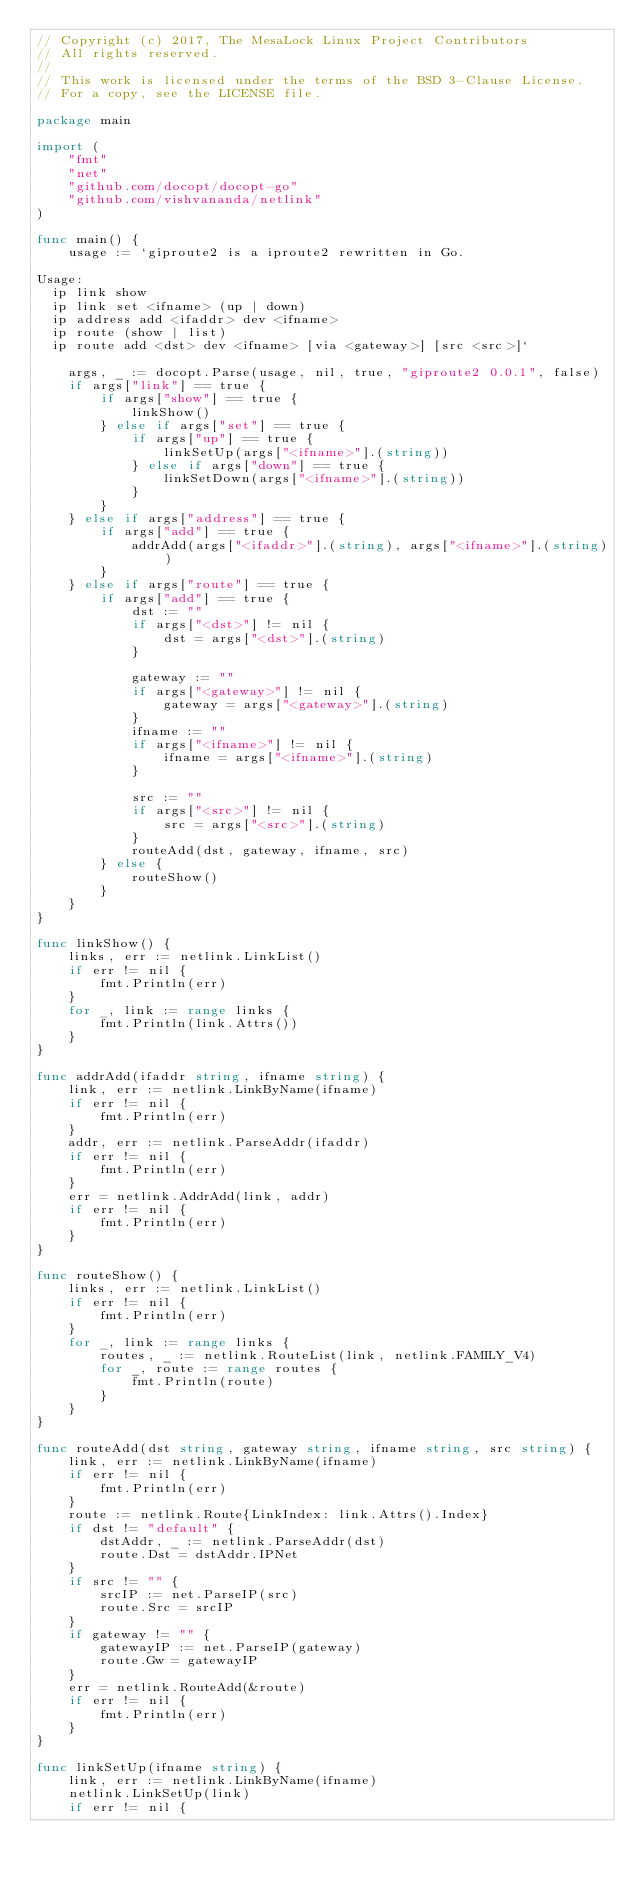Convert code to text. <code><loc_0><loc_0><loc_500><loc_500><_Go_>// Copyright (c) 2017, The MesaLock Linux Project Contributors
// All rights reserved.
//
// This work is licensed under the terms of the BSD 3-Clause License.
// For a copy, see the LICENSE file.

package main

import (
    "fmt"
    "net"
    "github.com/docopt/docopt-go"
    "github.com/vishvananda/netlink"
)

func main() {
    usage := `giproute2 is a iproute2 rewritten in Go.

Usage:
  ip link show
  ip link set <ifname> (up | down)
  ip address add <ifaddr> dev <ifname>
  ip route (show | list)
  ip route add <dst> dev <ifname> [via <gateway>] [src <src>]`

    args, _ := docopt.Parse(usage, nil, true, "giproute2 0.0.1", false)
    if args["link"] == true {
        if args["show"] == true {
            linkShow()
        } else if args["set"] == true {
            if args["up"] == true {
                linkSetUp(args["<ifname>"].(string))
            } else if args["down"] == true {
                linkSetDown(args["<ifname>"].(string))
            }
        }
    } else if args["address"] == true {
        if args["add"] == true {
            addrAdd(args["<ifaddr>"].(string), args["<ifname>"].(string))
        }
    } else if args["route"] == true {
        if args["add"] == true {
            dst := ""
            if args["<dst>"] != nil {
                dst = args["<dst>"].(string)
            }

            gateway := ""
            if args["<gateway>"] != nil {
                gateway = args["<gateway>"].(string)
            }
            ifname := ""
            if args["<ifname>"] != nil {
                ifname = args["<ifname>"].(string)
            }

            src := ""
            if args["<src>"] != nil {
                src = args["<src>"].(string)
            }
            routeAdd(dst, gateway, ifname, src)
        } else {
            routeShow()
        }
    }
}

func linkShow() {
    links, err := netlink.LinkList()
    if err != nil {
        fmt.Println(err)
    }
    for _, link := range links {
        fmt.Println(link.Attrs())
    }
}

func addrAdd(ifaddr string, ifname string) {
    link, err := netlink.LinkByName(ifname)
    if err != nil {
        fmt.Println(err)
    }
    addr, err := netlink.ParseAddr(ifaddr)
    if err != nil {
        fmt.Println(err)
    }
    err = netlink.AddrAdd(link, addr)
    if err != nil {
        fmt.Println(err)
    }
}

func routeShow() {
    links, err := netlink.LinkList()
    if err != nil {
        fmt.Println(err)
    }
    for _, link := range links {
        routes, _ := netlink.RouteList(link, netlink.FAMILY_V4)
        for _, route := range routes {
            fmt.Println(route)
        }
    }
}

func routeAdd(dst string, gateway string, ifname string, src string) {
    link, err := netlink.LinkByName(ifname)
    if err != nil {
        fmt.Println(err)
    }
    route := netlink.Route{LinkIndex: link.Attrs().Index}
    if dst != "default" {
        dstAddr, _ := netlink.ParseAddr(dst)
        route.Dst = dstAddr.IPNet
    }
    if src != "" {
        srcIP := net.ParseIP(src)
        route.Src = srcIP
    }
    if gateway != "" {
        gatewayIP := net.ParseIP(gateway)
        route.Gw = gatewayIP
    }
    err = netlink.RouteAdd(&route)
    if err != nil {
        fmt.Println(err)
    }
}

func linkSetUp(ifname string) {
    link, err := netlink.LinkByName(ifname)
    netlink.LinkSetUp(link)
    if err != nil {</code> 